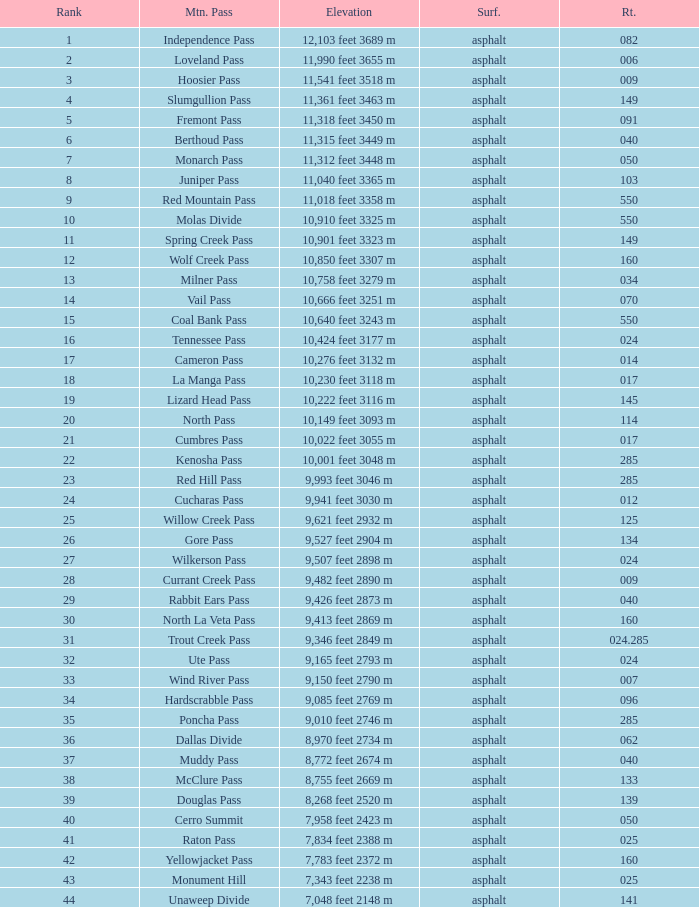What is the Surface of the Route less than 7? Asphalt. Can you give me this table as a dict? {'header': ['Rank', 'Mtn. Pass', 'Elevation', 'Surf.', 'Rt.'], 'rows': [['1', 'Independence Pass', '12,103 feet 3689 m', 'asphalt', '082'], ['2', 'Loveland Pass', '11,990 feet 3655 m', 'asphalt', '006'], ['3', 'Hoosier Pass', '11,541 feet 3518 m', 'asphalt', '009'], ['4', 'Slumgullion Pass', '11,361 feet 3463 m', 'asphalt', '149'], ['5', 'Fremont Pass', '11,318 feet 3450 m', 'asphalt', '091'], ['6', 'Berthoud Pass', '11,315 feet 3449 m', 'asphalt', '040'], ['7', 'Monarch Pass', '11,312 feet 3448 m', 'asphalt', '050'], ['8', 'Juniper Pass', '11,040 feet 3365 m', 'asphalt', '103'], ['9', 'Red Mountain Pass', '11,018 feet 3358 m', 'asphalt', '550'], ['10', 'Molas Divide', '10,910 feet 3325 m', 'asphalt', '550'], ['11', 'Spring Creek Pass', '10,901 feet 3323 m', 'asphalt', '149'], ['12', 'Wolf Creek Pass', '10,850 feet 3307 m', 'asphalt', '160'], ['13', 'Milner Pass', '10,758 feet 3279 m', 'asphalt', '034'], ['14', 'Vail Pass', '10,666 feet 3251 m', 'asphalt', '070'], ['15', 'Coal Bank Pass', '10,640 feet 3243 m', 'asphalt', '550'], ['16', 'Tennessee Pass', '10,424 feet 3177 m', 'asphalt', '024'], ['17', 'Cameron Pass', '10,276 feet 3132 m', 'asphalt', '014'], ['18', 'La Manga Pass', '10,230 feet 3118 m', 'asphalt', '017'], ['19', 'Lizard Head Pass', '10,222 feet 3116 m', 'asphalt', '145'], ['20', 'North Pass', '10,149 feet 3093 m', 'asphalt', '114'], ['21', 'Cumbres Pass', '10,022 feet 3055 m', 'asphalt', '017'], ['22', 'Kenosha Pass', '10,001 feet 3048 m', 'asphalt', '285'], ['23', 'Red Hill Pass', '9,993 feet 3046 m', 'asphalt', '285'], ['24', 'Cucharas Pass', '9,941 feet 3030 m', 'asphalt', '012'], ['25', 'Willow Creek Pass', '9,621 feet 2932 m', 'asphalt', '125'], ['26', 'Gore Pass', '9,527 feet 2904 m', 'asphalt', '134'], ['27', 'Wilkerson Pass', '9,507 feet 2898 m', 'asphalt', '024'], ['28', 'Currant Creek Pass', '9,482 feet 2890 m', 'asphalt', '009'], ['29', 'Rabbit Ears Pass', '9,426 feet 2873 m', 'asphalt', '040'], ['30', 'North La Veta Pass', '9,413 feet 2869 m', 'asphalt', '160'], ['31', 'Trout Creek Pass', '9,346 feet 2849 m', 'asphalt', '024.285'], ['32', 'Ute Pass', '9,165 feet 2793 m', 'asphalt', '024'], ['33', 'Wind River Pass', '9,150 feet 2790 m', 'asphalt', '007'], ['34', 'Hardscrabble Pass', '9,085 feet 2769 m', 'asphalt', '096'], ['35', 'Poncha Pass', '9,010 feet 2746 m', 'asphalt', '285'], ['36', 'Dallas Divide', '8,970 feet 2734 m', 'asphalt', '062'], ['37', 'Muddy Pass', '8,772 feet 2674 m', 'asphalt', '040'], ['38', 'McClure Pass', '8,755 feet 2669 m', 'asphalt', '133'], ['39', 'Douglas Pass', '8,268 feet 2520 m', 'asphalt', '139'], ['40', 'Cerro Summit', '7,958 feet 2423 m', 'asphalt', '050'], ['41', 'Raton Pass', '7,834 feet 2388 m', 'asphalt', '025'], ['42', 'Yellowjacket Pass', '7,783 feet 2372 m', 'asphalt', '160'], ['43', 'Monument Hill', '7,343 feet 2238 m', 'asphalt', '025'], ['44', 'Unaweep Divide', '7,048 feet 2148 m', 'asphalt', '141']]} 